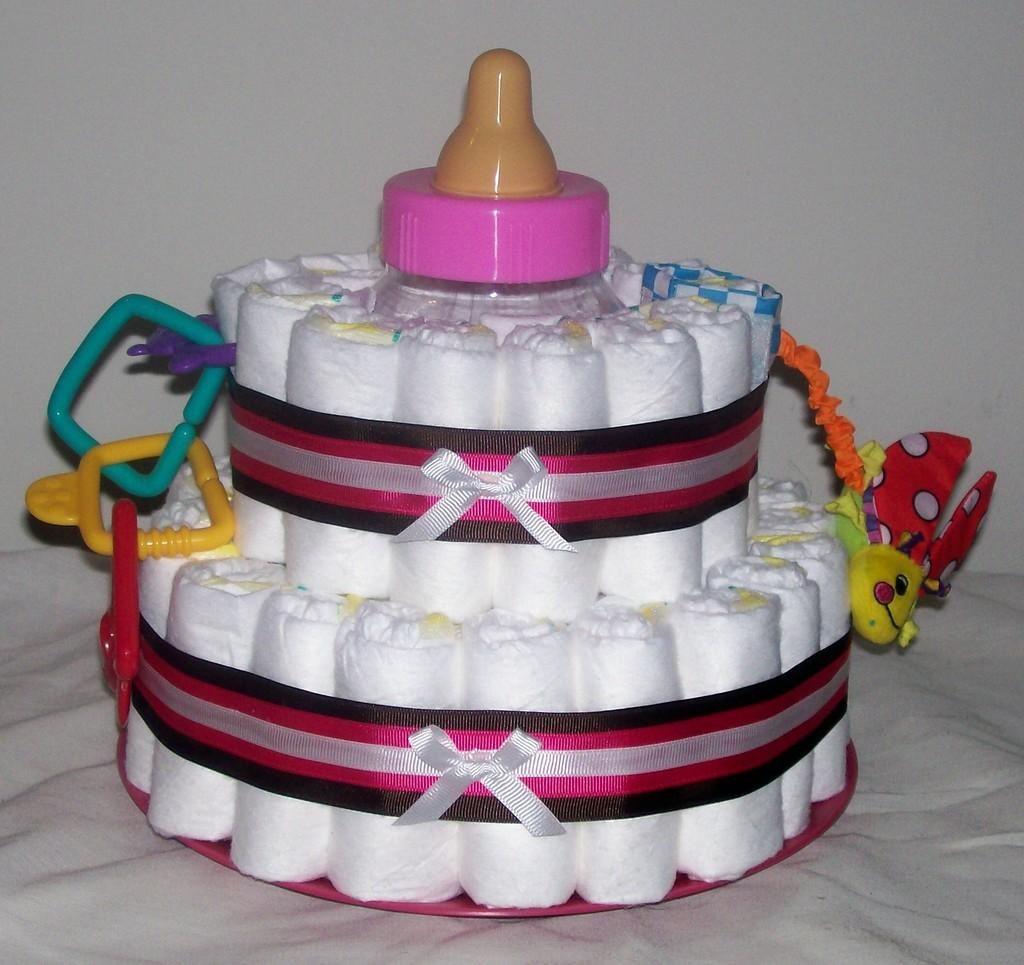What is the main subject of the image? There is a cake in the image. What can be observed about the surface the cake is placed on? The surface the cake is on is white in color. How many pets are visible in the image? There are no pets present in the image; it features a cake on a white surface. What type of milk is being used to decorate the cake in the image? There is no milk visible in the image, as it only shows a cake on a white surface. 